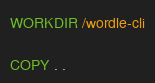<code> <loc_0><loc_0><loc_500><loc_500><_Dockerfile_>
WORKDIR /wordle-cli

COPY . .
</code> 